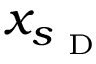Convert formula to latex. <formula><loc_0><loc_0><loc_500><loc_500>x _ { s _ { D } }</formula> 